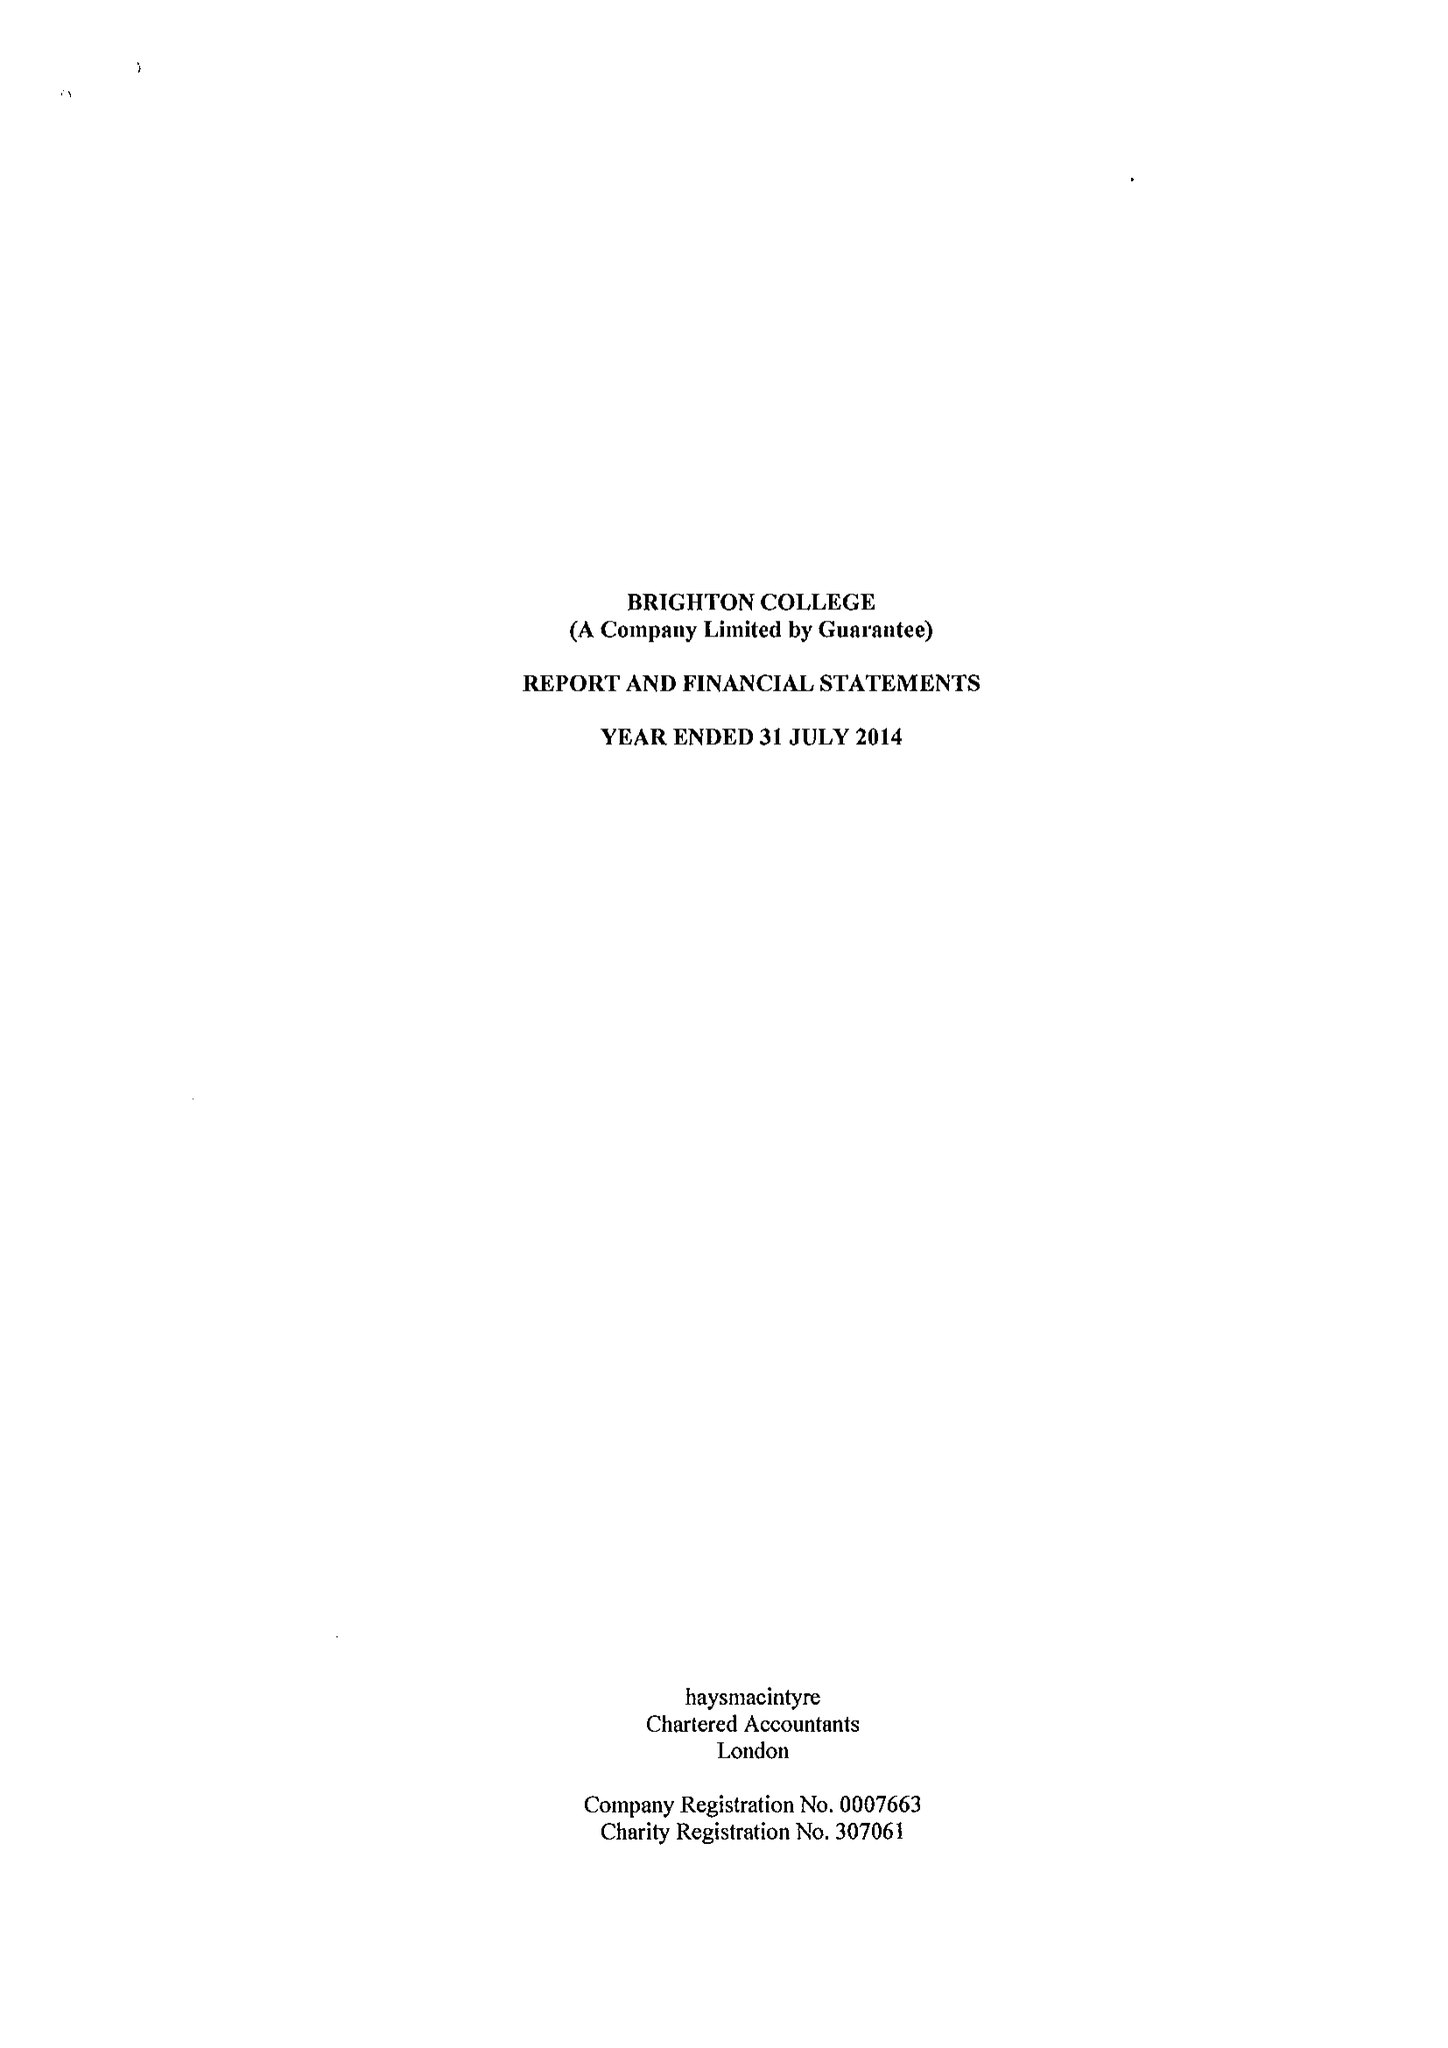What is the value for the report_date?
Answer the question using a single word or phrase. 2014-07-31 